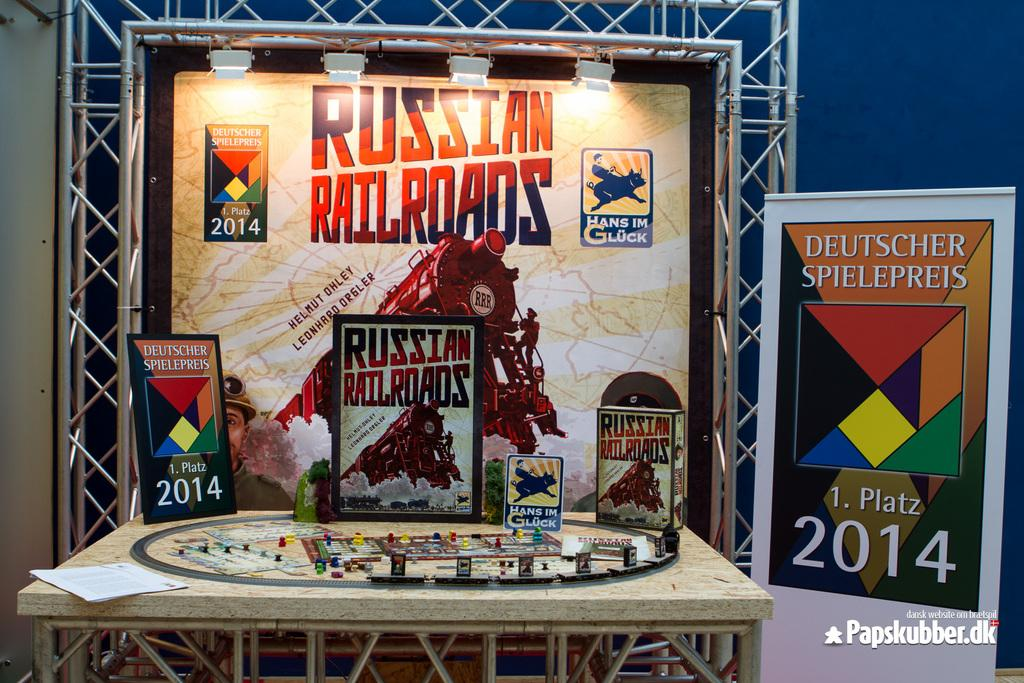<image>
Relay a brief, clear account of the picture shown. A Russian Railroads game is set up a a display table. 